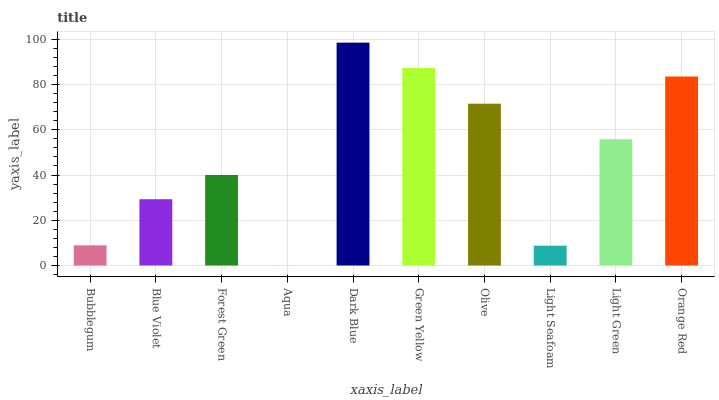Is Blue Violet the minimum?
Answer yes or no. No. Is Blue Violet the maximum?
Answer yes or no. No. Is Blue Violet greater than Bubblegum?
Answer yes or no. Yes. Is Bubblegum less than Blue Violet?
Answer yes or no. Yes. Is Bubblegum greater than Blue Violet?
Answer yes or no. No. Is Blue Violet less than Bubblegum?
Answer yes or no. No. Is Light Green the high median?
Answer yes or no. Yes. Is Forest Green the low median?
Answer yes or no. Yes. Is Forest Green the high median?
Answer yes or no. No. Is Aqua the low median?
Answer yes or no. No. 